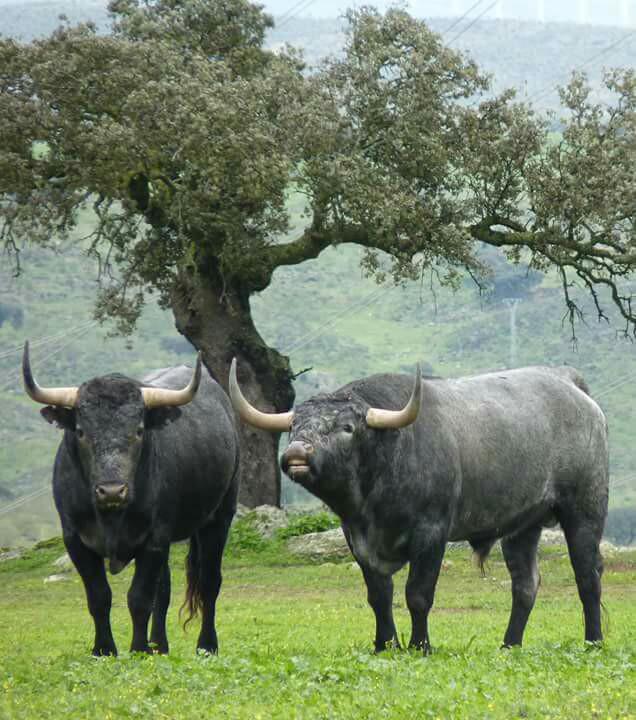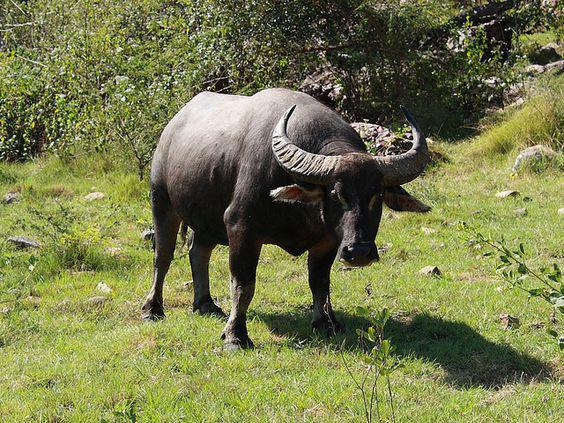The first image is the image on the left, the second image is the image on the right. Analyze the images presented: Is the assertion "The right image contains one forward-facing ox with a somewhat lowered head, and the left image shows two look-alike oxen standing on green grass." valid? Answer yes or no. Yes. The first image is the image on the left, the second image is the image on the right. Examine the images to the left and right. Is the description "One of the animals is wearing decorations." accurate? Answer yes or no. No. 